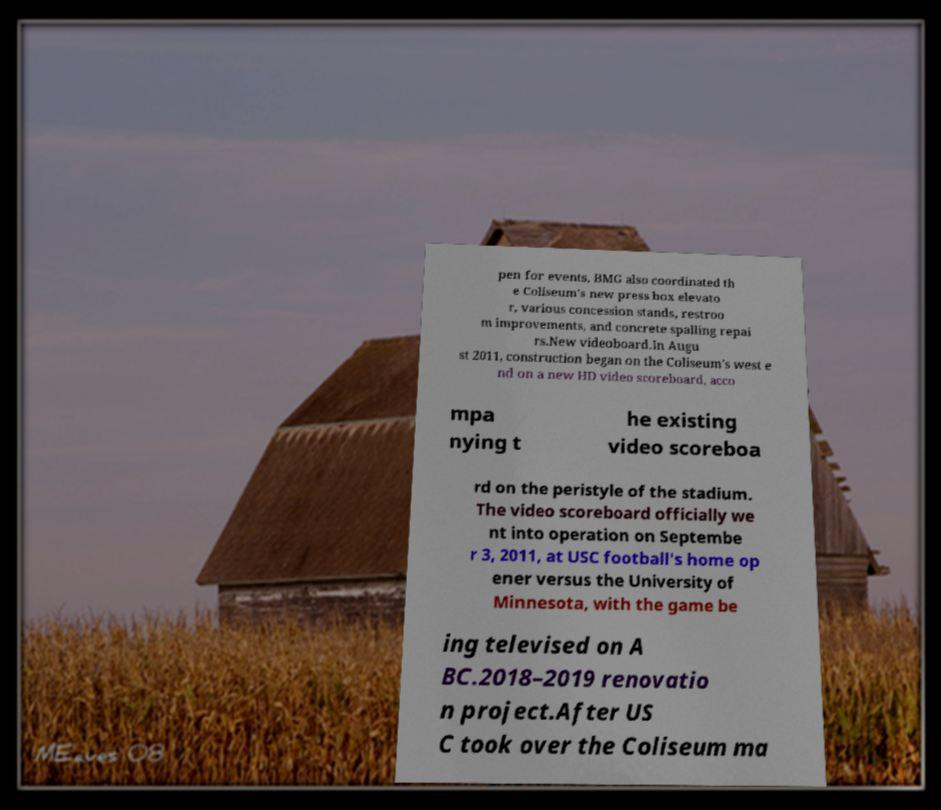There's text embedded in this image that I need extracted. Can you transcribe it verbatim? pen for events, BMG also coordinated th e Coliseum's new press box elevato r, various concession stands, restroo m improvements, and concrete spalling repai rs.New videoboard.In Augu st 2011, construction began on the Coliseum's west e nd on a new HD video scoreboard, acco mpa nying t he existing video scoreboa rd on the peristyle of the stadium. The video scoreboard officially we nt into operation on Septembe r 3, 2011, at USC football's home op ener versus the University of Minnesota, with the game be ing televised on A BC.2018–2019 renovatio n project.After US C took over the Coliseum ma 